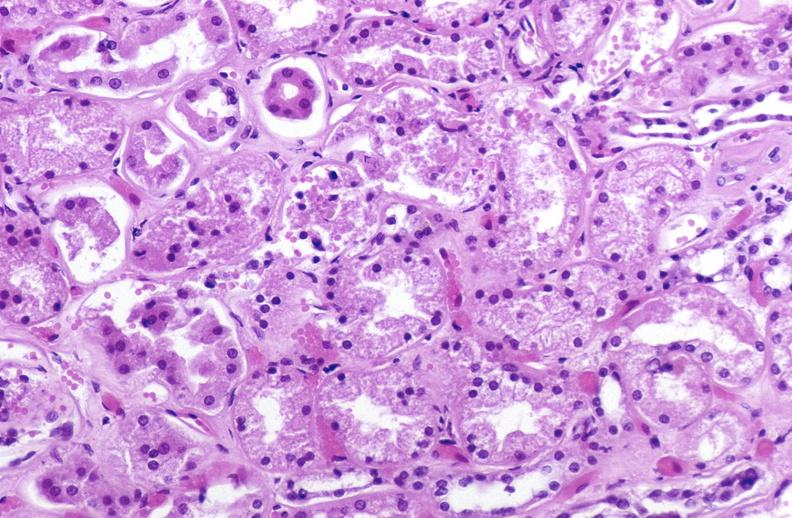what does this image show?
Answer the question using a single word or phrase. Atn acute tubular necrosis 